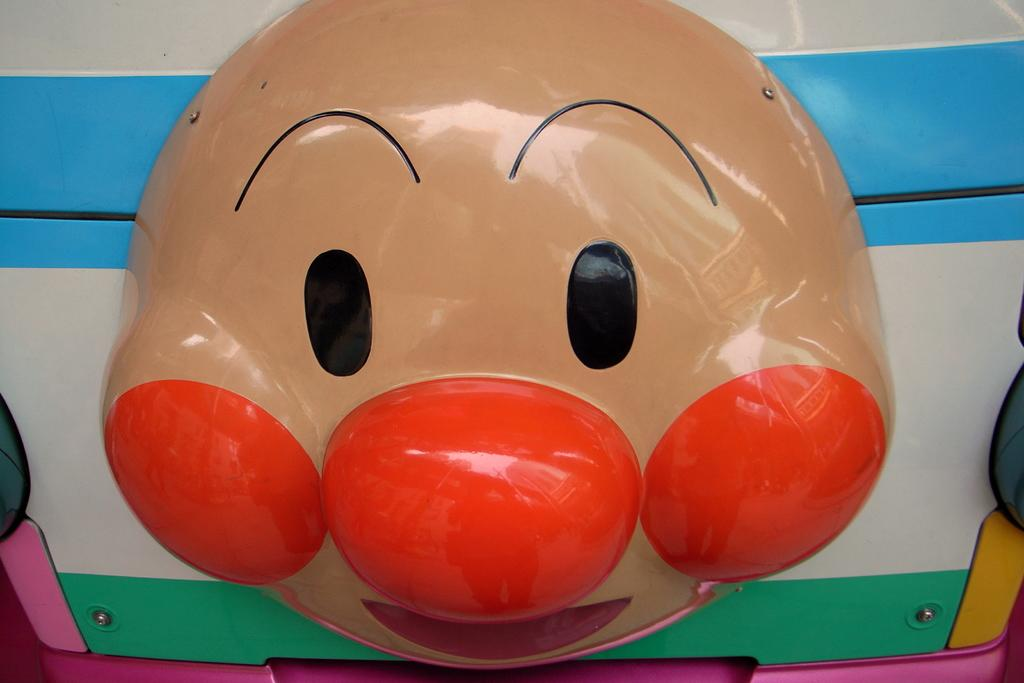What is the main subject of the image? The main subject of the image is a face-shaped object. How is the face-shaped object connected to another object? The face-shaped object is attached to another object. What type of air is being used to power the sister's lumber mill in the image? There is no mention of a sister, lumber mill, or air in the image, so it is not possible to answer that question. 